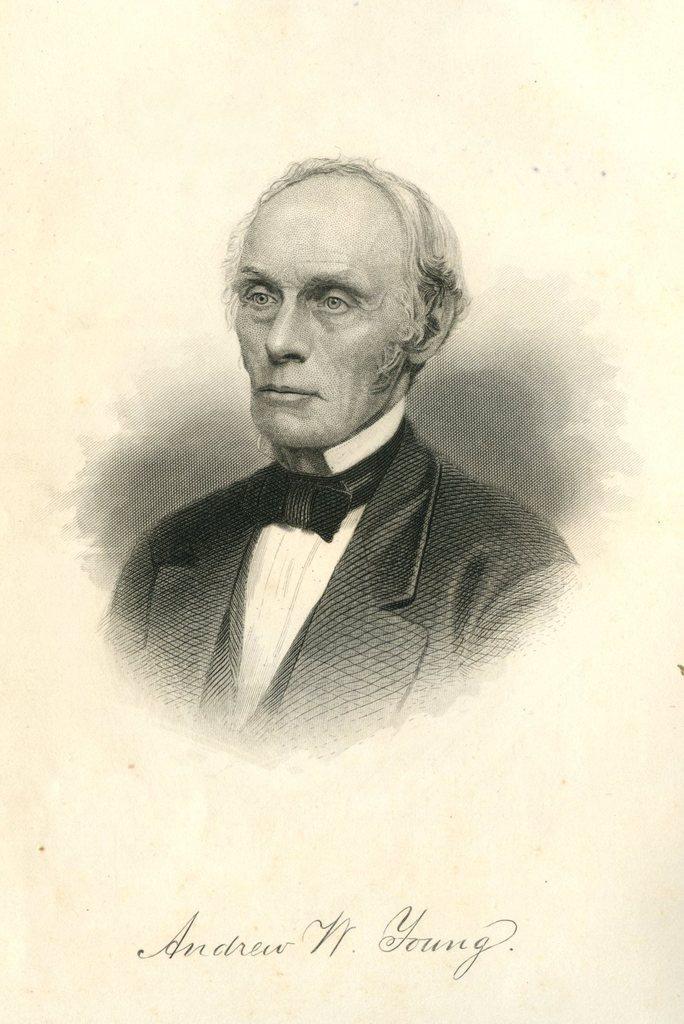Please provide a concise description of this image. This picture is a painting. In the center of the picture there is a person wearing suit. At the bottom there is text. 